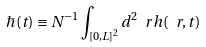<formula> <loc_0><loc_0><loc_500><loc_500>\hbar { ( } t ) \equiv N ^ { - 1 } \int _ { [ 0 , L ] ^ { 2 } } d ^ { 2 } \ r h ( \ r , t )</formula> 